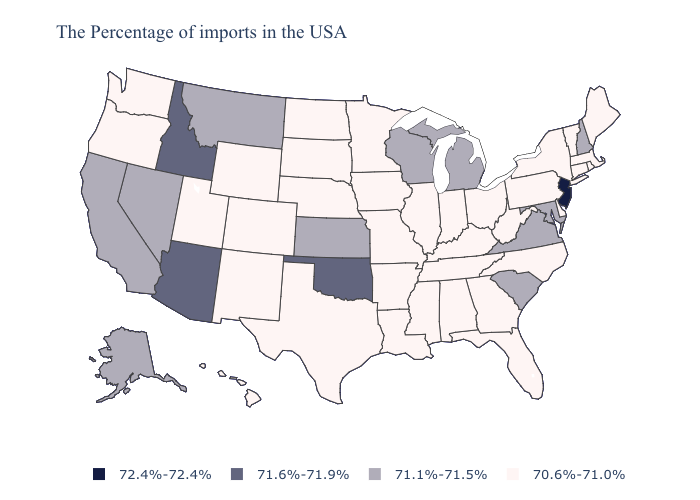Does Connecticut have the highest value in the USA?
Concise answer only. No. What is the lowest value in the Northeast?
Keep it brief. 70.6%-71.0%. Name the states that have a value in the range 70.6%-71.0%?
Answer briefly. Maine, Massachusetts, Rhode Island, Vermont, Connecticut, New York, Delaware, Pennsylvania, North Carolina, West Virginia, Ohio, Florida, Georgia, Kentucky, Indiana, Alabama, Tennessee, Illinois, Mississippi, Louisiana, Missouri, Arkansas, Minnesota, Iowa, Nebraska, Texas, South Dakota, North Dakota, Wyoming, Colorado, New Mexico, Utah, Washington, Oregon, Hawaii. What is the value of Iowa?
Give a very brief answer. 70.6%-71.0%. How many symbols are there in the legend?
Answer briefly. 4. What is the value of Pennsylvania?
Quick response, please. 70.6%-71.0%. Which states have the highest value in the USA?
Concise answer only. New Jersey. What is the highest value in states that border Texas?
Answer briefly. 71.6%-71.9%. Name the states that have a value in the range 70.6%-71.0%?
Keep it brief. Maine, Massachusetts, Rhode Island, Vermont, Connecticut, New York, Delaware, Pennsylvania, North Carolina, West Virginia, Ohio, Florida, Georgia, Kentucky, Indiana, Alabama, Tennessee, Illinois, Mississippi, Louisiana, Missouri, Arkansas, Minnesota, Iowa, Nebraska, Texas, South Dakota, North Dakota, Wyoming, Colorado, New Mexico, Utah, Washington, Oregon, Hawaii. Does Mississippi have the highest value in the USA?
Concise answer only. No. What is the value of Colorado?
Short answer required. 70.6%-71.0%. Name the states that have a value in the range 71.1%-71.5%?
Write a very short answer. New Hampshire, Maryland, Virginia, South Carolina, Michigan, Wisconsin, Kansas, Montana, Nevada, California, Alaska. What is the value of Minnesota?
Be succinct. 70.6%-71.0%. Name the states that have a value in the range 71.1%-71.5%?
Short answer required. New Hampshire, Maryland, Virginia, South Carolina, Michigan, Wisconsin, Kansas, Montana, Nevada, California, Alaska. What is the value of Delaware?
Give a very brief answer. 70.6%-71.0%. 